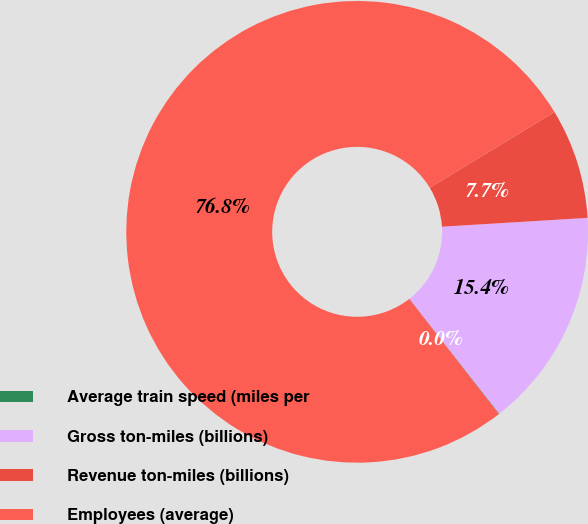<chart> <loc_0><loc_0><loc_500><loc_500><pie_chart><fcel>Average train speed (miles per<fcel>Gross ton-miles (billions)<fcel>Revenue ton-miles (billions)<fcel>Employees (average)<nl><fcel>0.04%<fcel>15.4%<fcel>7.72%<fcel>76.83%<nl></chart> 